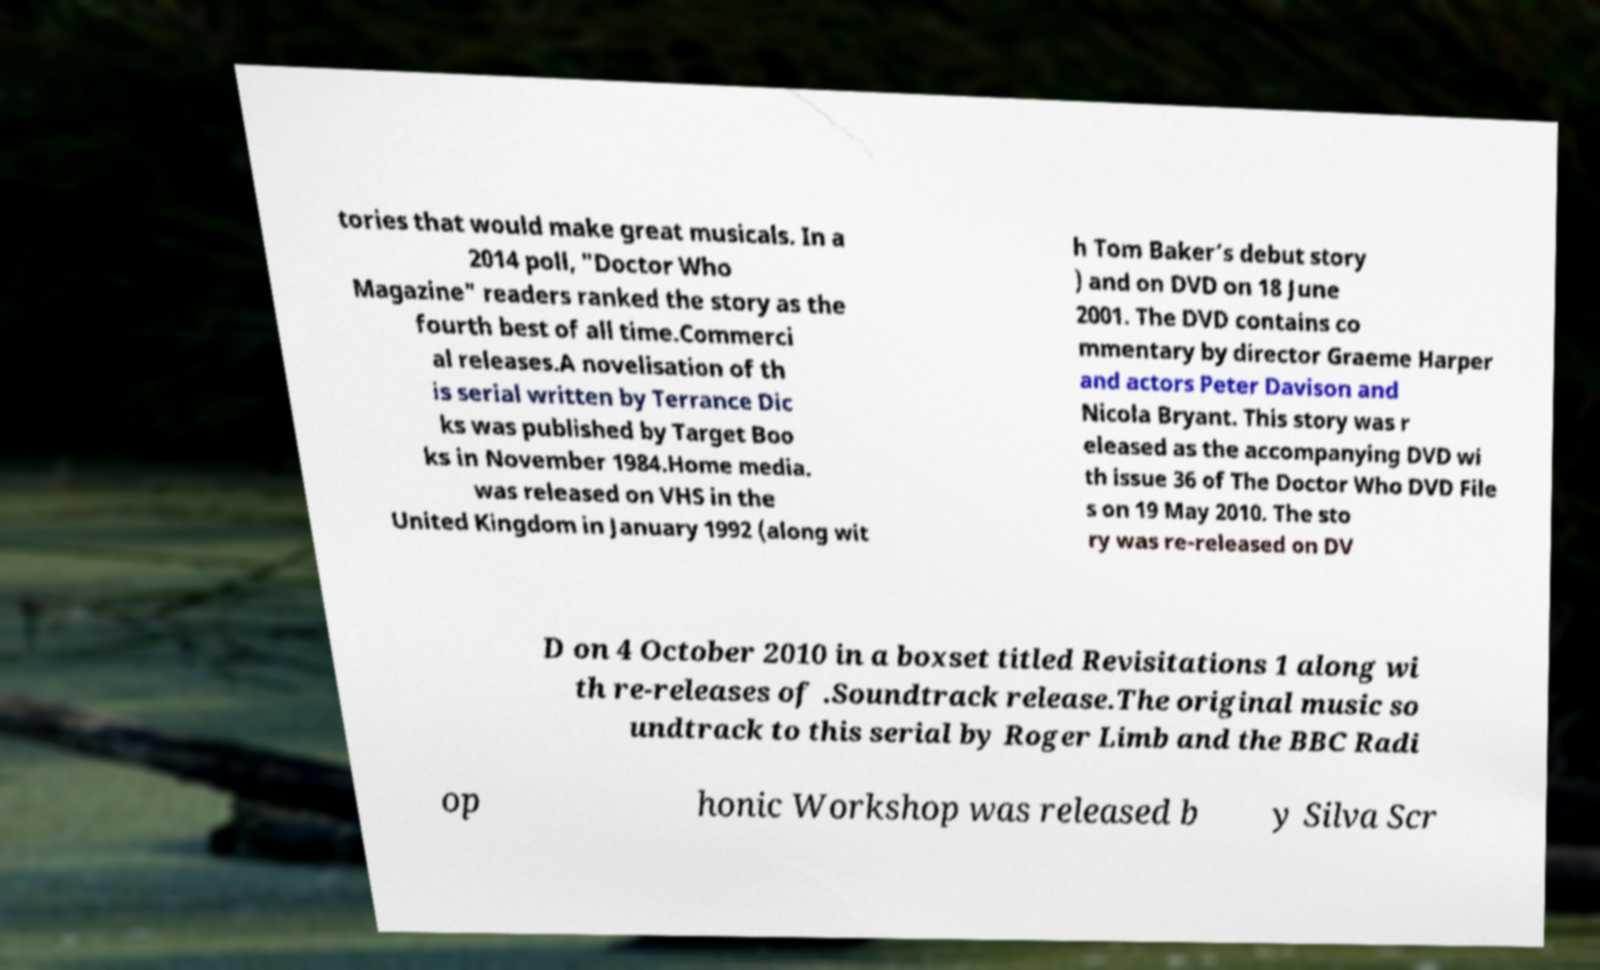Could you assist in decoding the text presented in this image and type it out clearly? tories that would make great musicals. In a 2014 poll, "Doctor Who Magazine" readers ranked the story as the fourth best of all time.Commerci al releases.A novelisation of th is serial written by Terrance Dic ks was published by Target Boo ks in November 1984.Home media. was released on VHS in the United Kingdom in January 1992 (along wit h Tom Baker’s debut story ) and on DVD on 18 June 2001. The DVD contains co mmentary by director Graeme Harper and actors Peter Davison and Nicola Bryant. This story was r eleased as the accompanying DVD wi th issue 36 of The Doctor Who DVD File s on 19 May 2010. The sto ry was re-released on DV D on 4 October 2010 in a boxset titled Revisitations 1 along wi th re-releases of .Soundtrack release.The original music so undtrack to this serial by Roger Limb and the BBC Radi op honic Workshop was released b y Silva Scr 